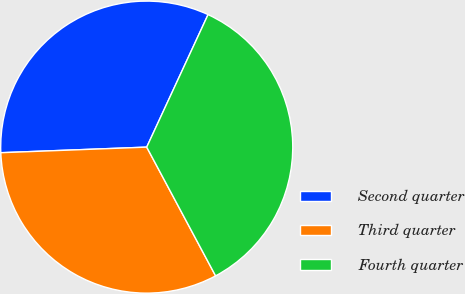Convert chart. <chart><loc_0><loc_0><loc_500><loc_500><pie_chart><fcel>Second quarter<fcel>Third quarter<fcel>Fourth quarter<nl><fcel>32.51%<fcel>32.21%<fcel>35.28%<nl></chart> 